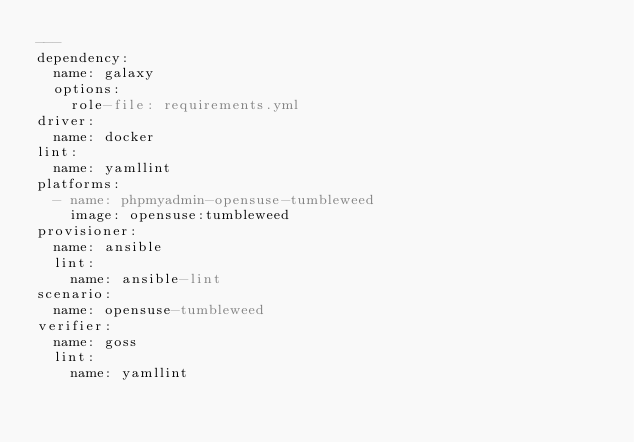<code> <loc_0><loc_0><loc_500><loc_500><_YAML_>---
dependency:
  name: galaxy
  options:
    role-file: requirements.yml
driver:
  name: docker
lint:
  name: yamllint
platforms:
  - name: phpmyadmin-opensuse-tumbleweed
    image: opensuse:tumbleweed
provisioner:
  name: ansible
  lint:
    name: ansible-lint
scenario:
  name: opensuse-tumbleweed
verifier:
  name: goss
  lint:
    name: yamllint
</code> 